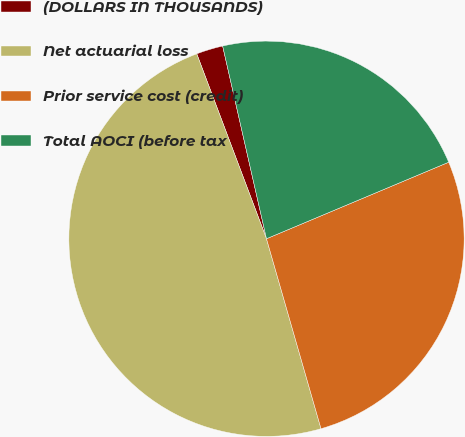Convert chart. <chart><loc_0><loc_0><loc_500><loc_500><pie_chart><fcel>(DOLLARS IN THOUSANDS)<fcel>Net actuarial loss<fcel>Prior service cost (credit)<fcel>Total AOCI (before tax<nl><fcel>2.18%<fcel>48.71%<fcel>26.88%<fcel>22.23%<nl></chart> 